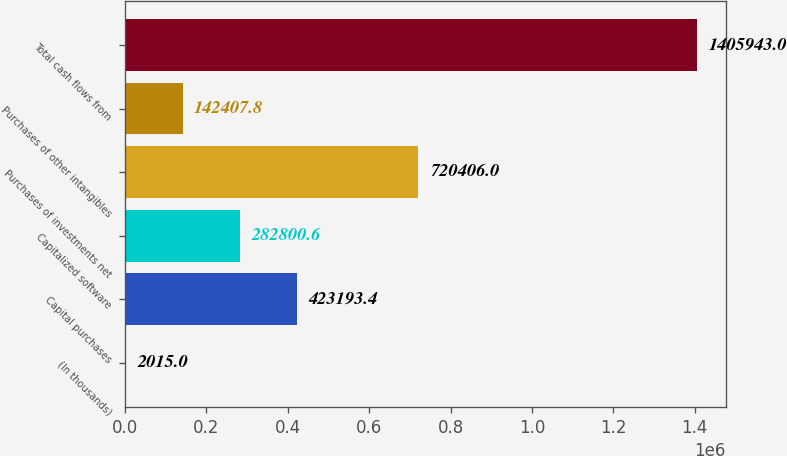Convert chart to OTSL. <chart><loc_0><loc_0><loc_500><loc_500><bar_chart><fcel>(In thousands)<fcel>Capital purchases<fcel>Capitalized software<fcel>Purchases of investments net<fcel>Purchases of other intangibles<fcel>Total cash flows from<nl><fcel>2015<fcel>423193<fcel>282801<fcel>720406<fcel>142408<fcel>1.40594e+06<nl></chart> 